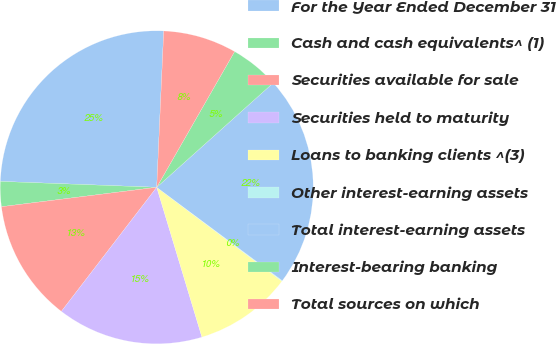Convert chart. <chart><loc_0><loc_0><loc_500><loc_500><pie_chart><fcel>For the Year Ended December 31<fcel>Cash and cash equivalents^ (1)<fcel>Securities available for sale<fcel>Securities held to maturity<fcel>Loans to banking clients ^(3)<fcel>Other interest-earning assets<fcel>Total interest-earning assets<fcel>Interest-bearing banking<fcel>Total sources on which<nl><fcel>25.11%<fcel>2.58%<fcel>12.59%<fcel>15.09%<fcel>10.09%<fcel>0.07%<fcel>21.8%<fcel>5.08%<fcel>7.58%<nl></chart> 